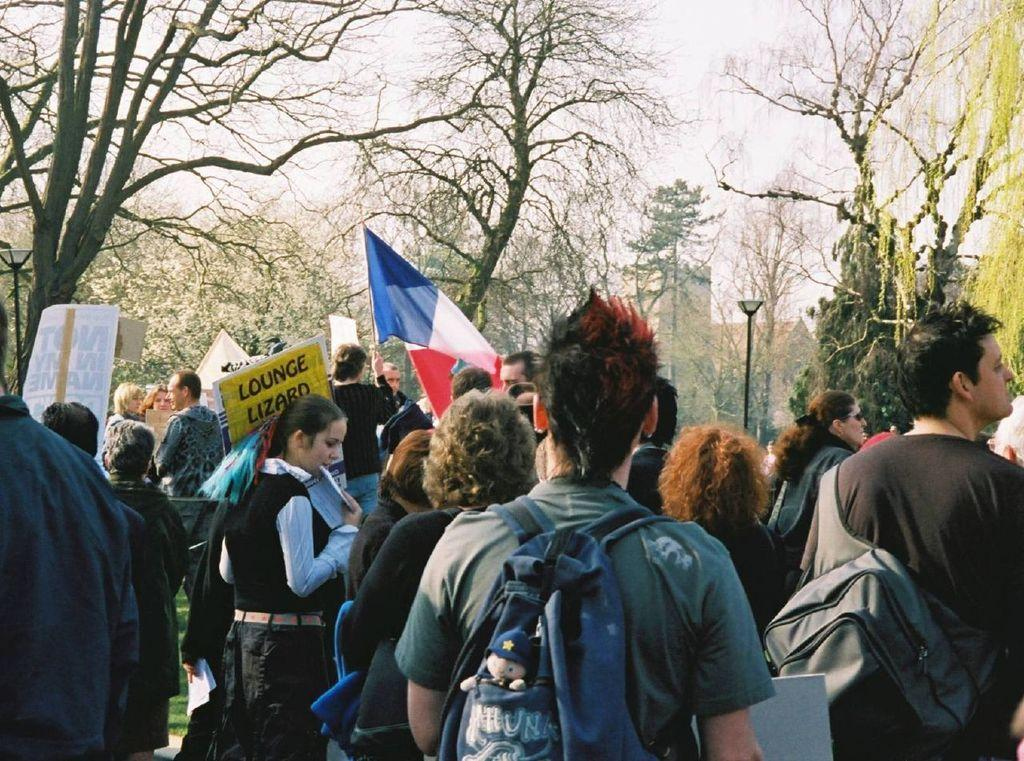Who is present in the image? There are people in the image. What are the people in the image doing? The people are protesting. What are the protesters holding in the image? The protesters are holding banners and flags. What can be seen in the background of the image? There are trees and a pole in the background of the image. What is the color of the sky in the image? The sky is white in color. What type of cent can be seen on the farm in the image? There is no cent or farm present in the image; it features people protesting with banners and flags. What is the chance of rain in the image? The image does not provide any information about the weather or the chance of rain. 